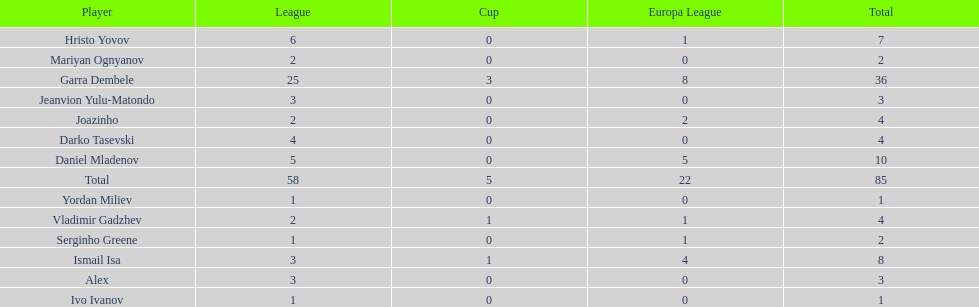How many players did not score a goal in cup play? 10. 